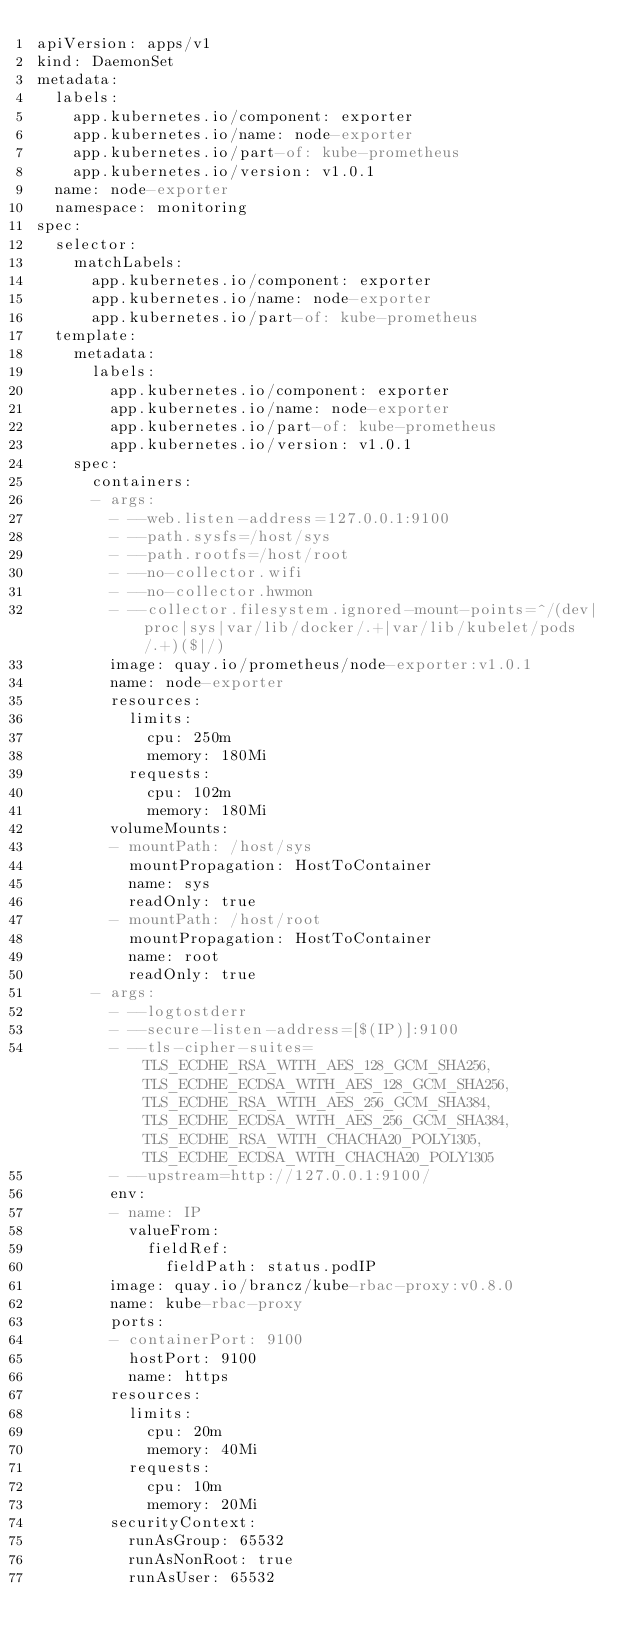Convert code to text. <code><loc_0><loc_0><loc_500><loc_500><_YAML_>apiVersion: apps/v1
kind: DaemonSet
metadata:
  labels:
    app.kubernetes.io/component: exporter
    app.kubernetes.io/name: node-exporter
    app.kubernetes.io/part-of: kube-prometheus
    app.kubernetes.io/version: v1.0.1
  name: node-exporter
  namespace: monitoring
spec:
  selector:
    matchLabels:
      app.kubernetes.io/component: exporter
      app.kubernetes.io/name: node-exporter
      app.kubernetes.io/part-of: kube-prometheus
  template:
    metadata:
      labels:
        app.kubernetes.io/component: exporter
        app.kubernetes.io/name: node-exporter
        app.kubernetes.io/part-of: kube-prometheus
        app.kubernetes.io/version: v1.0.1
    spec:
      containers:
      - args:
        - --web.listen-address=127.0.0.1:9100
        - --path.sysfs=/host/sys
        - --path.rootfs=/host/root
        - --no-collector.wifi
        - --no-collector.hwmon
        - --collector.filesystem.ignored-mount-points=^/(dev|proc|sys|var/lib/docker/.+|var/lib/kubelet/pods/.+)($|/)
        image: quay.io/prometheus/node-exporter:v1.0.1
        name: node-exporter
        resources:
          limits:
            cpu: 250m
            memory: 180Mi
          requests:
            cpu: 102m
            memory: 180Mi
        volumeMounts:
        - mountPath: /host/sys
          mountPropagation: HostToContainer
          name: sys
          readOnly: true
        - mountPath: /host/root
          mountPropagation: HostToContainer
          name: root
          readOnly: true
      - args:
        - --logtostderr
        - --secure-listen-address=[$(IP)]:9100
        - --tls-cipher-suites=TLS_ECDHE_RSA_WITH_AES_128_GCM_SHA256,TLS_ECDHE_ECDSA_WITH_AES_128_GCM_SHA256,TLS_ECDHE_RSA_WITH_AES_256_GCM_SHA384,TLS_ECDHE_ECDSA_WITH_AES_256_GCM_SHA384,TLS_ECDHE_RSA_WITH_CHACHA20_POLY1305,TLS_ECDHE_ECDSA_WITH_CHACHA20_POLY1305
        - --upstream=http://127.0.0.1:9100/
        env:
        - name: IP
          valueFrom:
            fieldRef:
              fieldPath: status.podIP
        image: quay.io/brancz/kube-rbac-proxy:v0.8.0
        name: kube-rbac-proxy
        ports:
        - containerPort: 9100
          hostPort: 9100
          name: https
        resources:
          limits:
            cpu: 20m
            memory: 40Mi
          requests:
            cpu: 10m
            memory: 20Mi
        securityContext:
          runAsGroup: 65532
          runAsNonRoot: true
          runAsUser: 65532</code> 